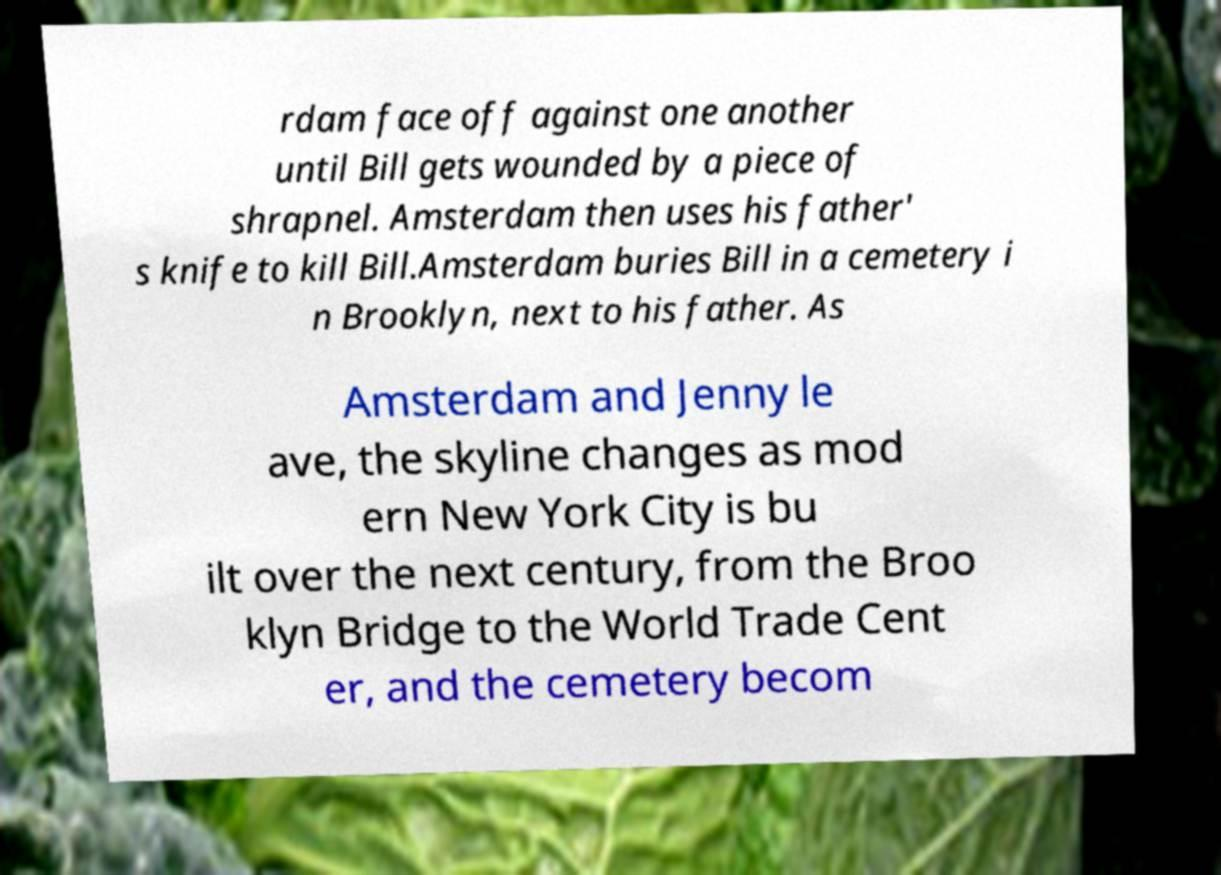Can you accurately transcribe the text from the provided image for me? rdam face off against one another until Bill gets wounded by a piece of shrapnel. Amsterdam then uses his father' s knife to kill Bill.Amsterdam buries Bill in a cemetery i n Brooklyn, next to his father. As Amsterdam and Jenny le ave, the skyline changes as mod ern New York City is bu ilt over the next century, from the Broo klyn Bridge to the World Trade Cent er, and the cemetery becom 